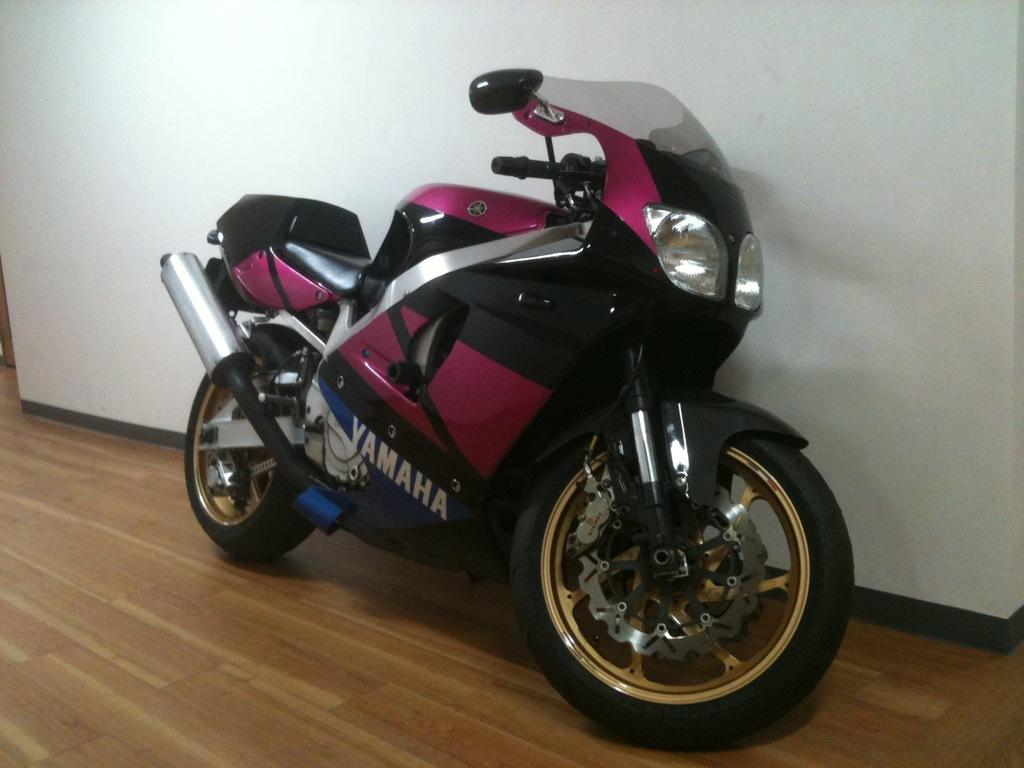What is the main subject in the center of the image? There is a bike in the center of the image. What can be seen in the background of the image? There is a wall in the background of the image. What is visible at the bottom of the image? There is a floor visible at the bottom of the image. What type of humor can be seen in the clouds in the image? There are no clouds present in the image, so it is not possible to determine if there is any humor in them. 